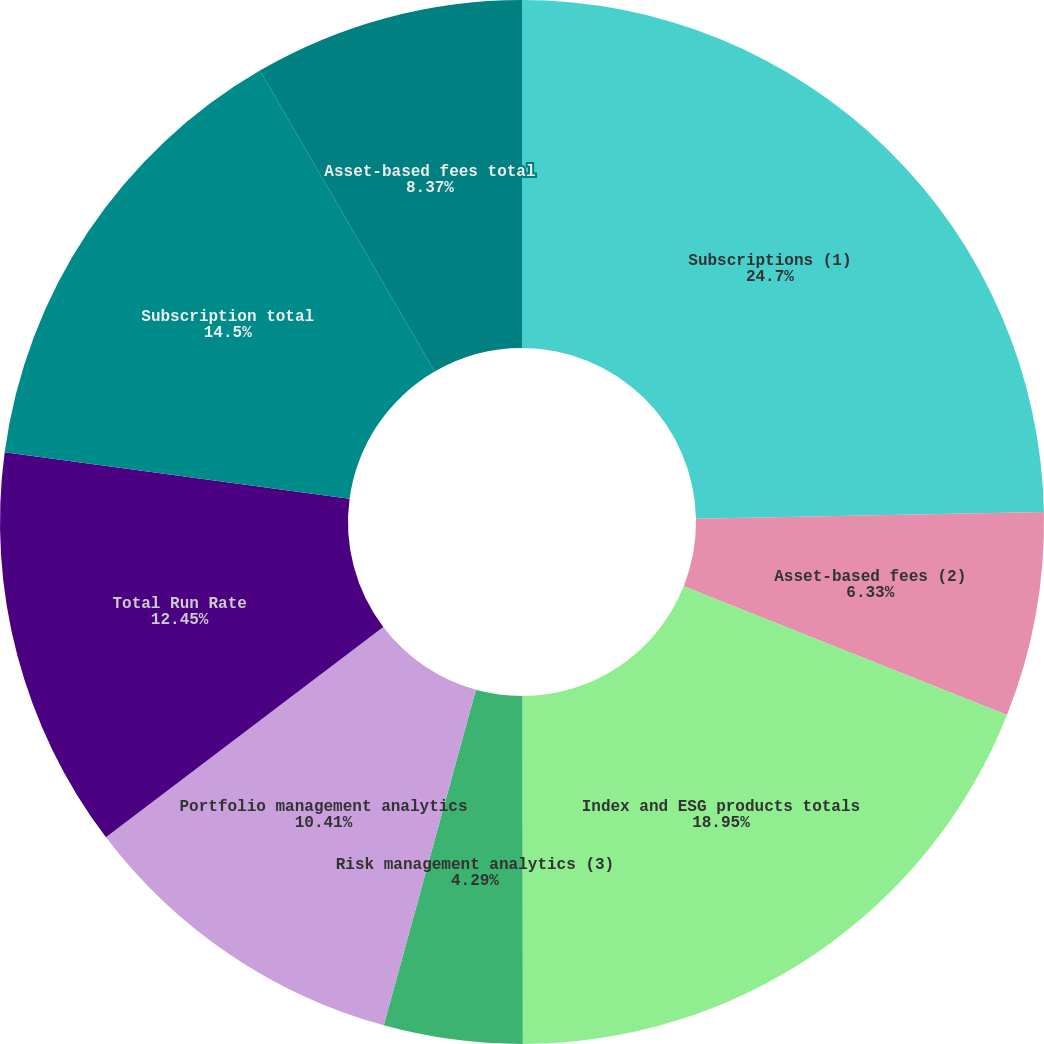<chart> <loc_0><loc_0><loc_500><loc_500><pie_chart><fcel>Subscriptions (1)<fcel>Asset-based fees (2)<fcel>Index and ESG products totals<fcel>Risk management analytics (3)<fcel>Portfolio management analytics<fcel>Total Run Rate<fcel>Subscription total<fcel>Asset-based fees total<nl><fcel>24.69%<fcel>6.33%<fcel>18.94%<fcel>4.29%<fcel>10.41%<fcel>12.45%<fcel>14.49%<fcel>8.37%<nl></chart> 